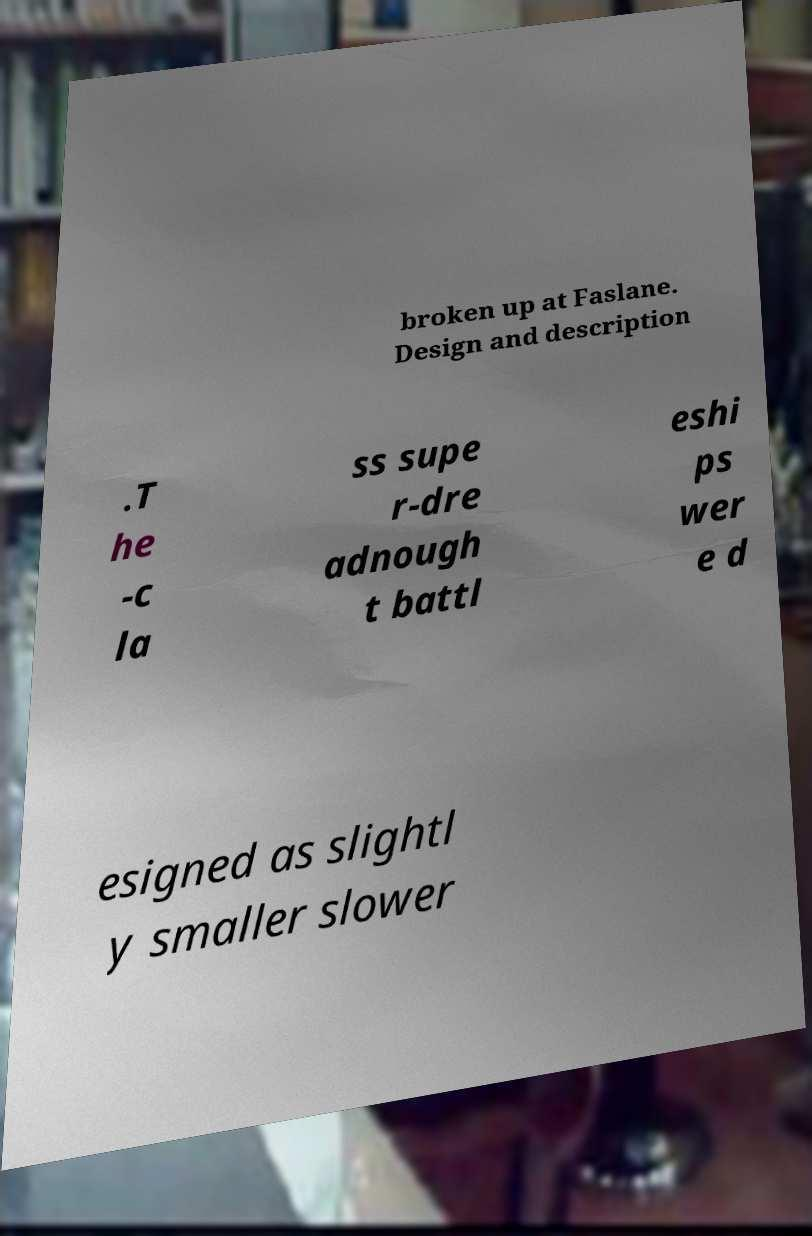Please identify and transcribe the text found in this image. broken up at Faslane. Design and description .T he -c la ss supe r-dre adnough t battl eshi ps wer e d esigned as slightl y smaller slower 